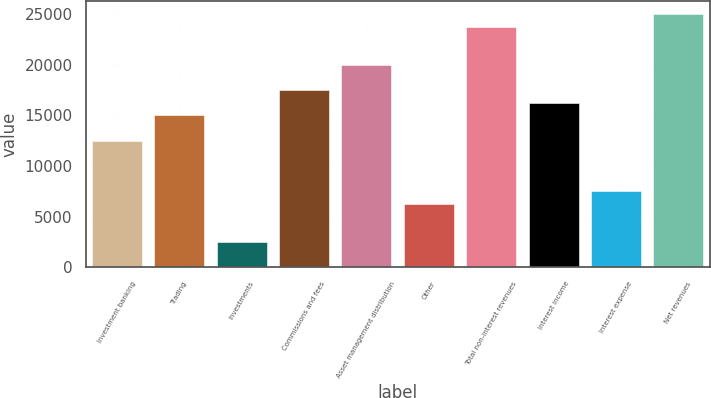Convert chart. <chart><loc_0><loc_0><loc_500><loc_500><bar_chart><fcel>Investment banking<fcel>Trading<fcel>Investments<fcel>Commissions and fees<fcel>Asset management distribution<fcel>Other<fcel>Total non-interest revenues<fcel>Interest income<fcel>Interest expense<fcel>Net revenues<nl><fcel>12519<fcel>15021.2<fcel>2510.2<fcel>17523.4<fcel>20025.6<fcel>6263.5<fcel>23778.9<fcel>16272.3<fcel>7514.6<fcel>25030<nl></chart> 